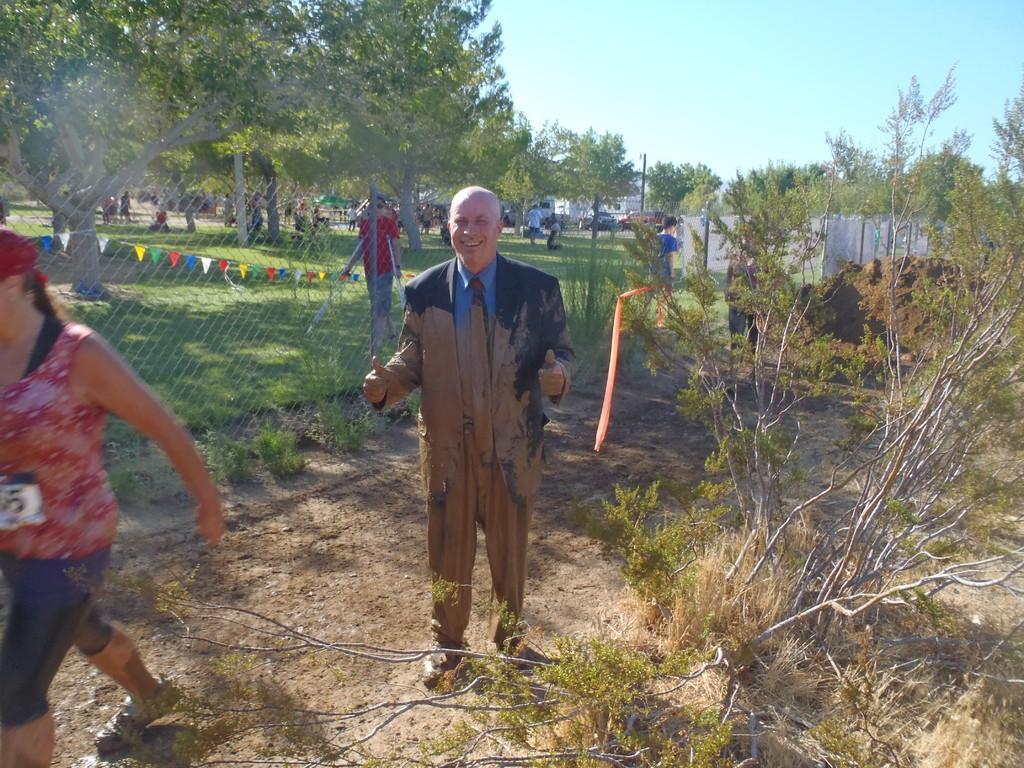In one or two sentences, can you explain what this image depicts? In this image we can see people, ground, grass, plants, poles, mesh, flags, wall, trees, and vehicles. In the background there is sky. 